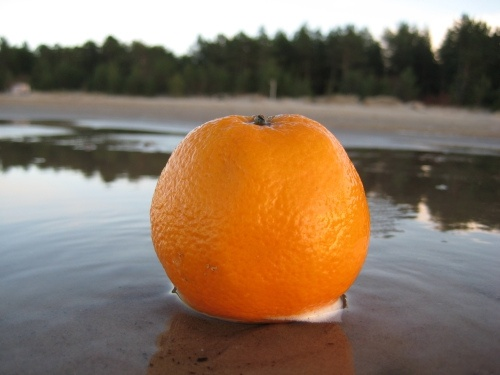Describe the objects in this image and their specific colors. I can see a orange in white, red, and orange tones in this image. 